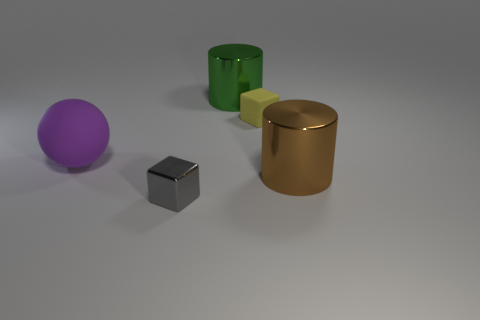Add 1 gray matte cylinders. How many objects exist? 6 Subtract all cylinders. How many objects are left? 3 Add 3 gray objects. How many gray objects exist? 4 Subtract 1 green cylinders. How many objects are left? 4 Subtract all big purple matte things. Subtract all big green things. How many objects are left? 3 Add 5 rubber cubes. How many rubber cubes are left? 6 